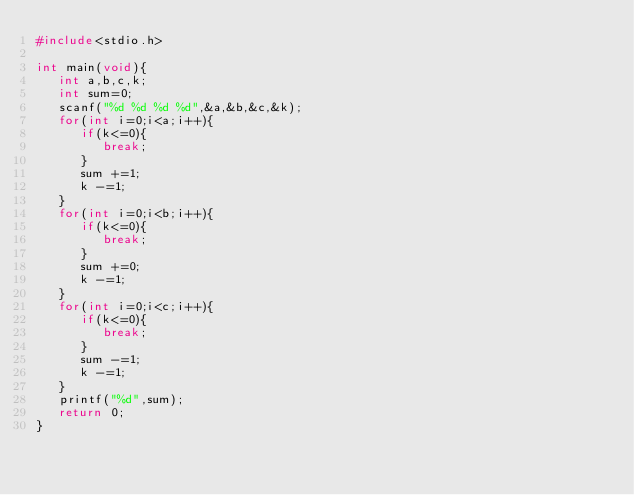<code> <loc_0><loc_0><loc_500><loc_500><_C_>#include<stdio.h>

int main(void){
   int a,b,c,k;
   int sum=0;
   scanf("%d %d %d %d",&a,&b,&c,&k);
   for(int i=0;i<a;i++){
      if(k<=0){
         break;
      }
      sum +=1;
      k -=1;
   }
   for(int i=0;i<b;i++){
      if(k<=0){
         break;
      }
      sum +=0;
      k -=1;
   }
   for(int i=0;i<c;i++){
      if(k<=0){
         break;
      }
      sum -=1;
      k -=1;
   }
   printf("%d",sum);
   return 0;
}
         
</code> 